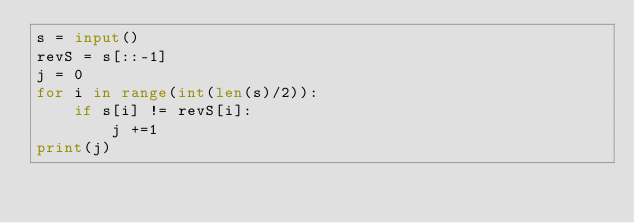<code> <loc_0><loc_0><loc_500><loc_500><_Python_>s = input()
revS = s[::-1]
j = 0
for i in range(int(len(s)/2)):
    if s[i] != revS[i]:
        j +=1
print(j)</code> 